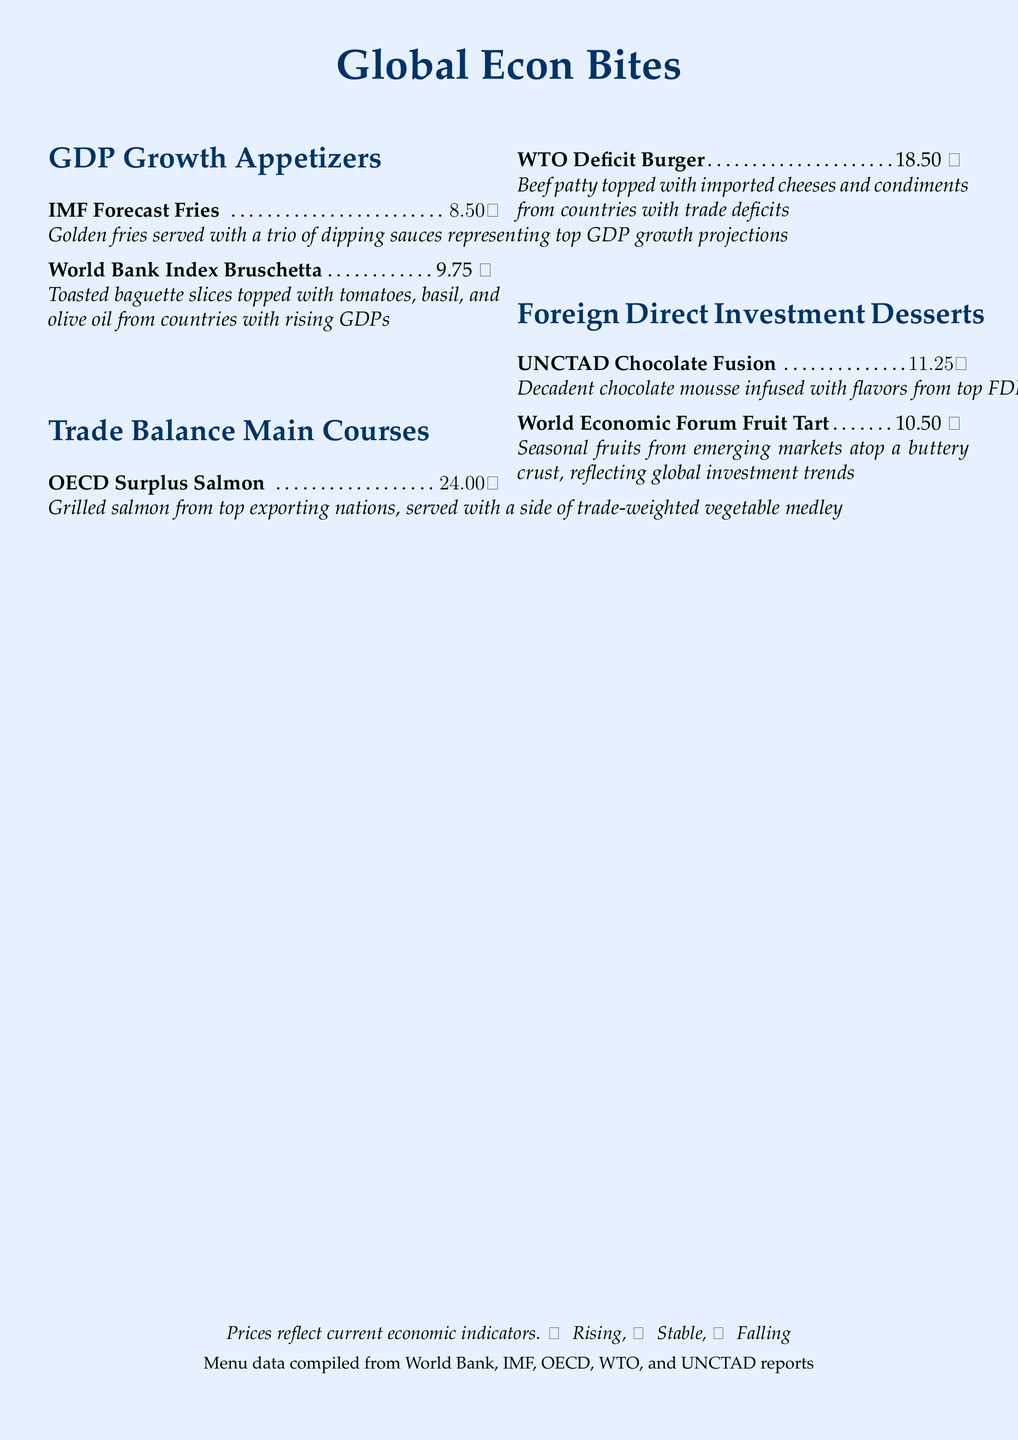What is the price of IMF Forecast Fries? The price of IMF Forecast Fries is explicitly stated in the menu section for GDP Growth Appetizers.
Answer: $8.50 Which dessert is inspired by UNCTAD? The menu lists UNCTAD Chocolate Fusion as a dessert inspired by flavors from top FDI recipient countries.
Answer: UNCTAD Chocolate Fusion What color indicates a rising price trend? The menu uses specific colors to represent price trends, and '↑' indicates prices that are rising.
Answer: Light blue How many appetizers are listed in the menu? The menu section for GDP Growth Appetizers contains two distinct items.
Answer: 2 What ingredient is common in the World Bank Index Bruschetta? The ingredient topped on toasted baguette slices in the World Bank Index Bruschetta is tomatoes.
Answer: Tomatoes Which main course has a falling price trend? The menu states that the WTO Deficit Burger has a price trend that is decreasing.
Answer: WTO Deficit Burger What type of fruit is featured in the World Economic Forum Fruit Tart? The dessert features seasonal fruits reflecting global investment trends.
Answer: Seasonal fruits What is the total price of the main courses? The total price is the sum of both main courses, $24.00 for OECD Surplus Salmon and $18.50 for WTO Deficit Burger.
Answer: $42.50 How is the price menu related to economic indicators? The menu explicitly states that prices reflect current economic indicators based on various international reports.
Answer: Current economic indicators 